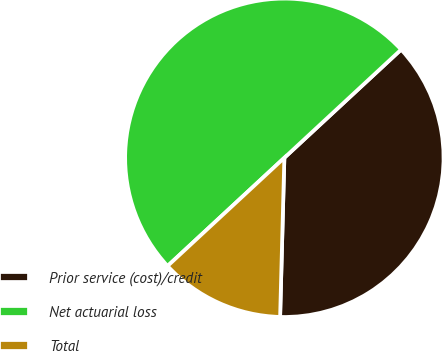Convert chart to OTSL. <chart><loc_0><loc_0><loc_500><loc_500><pie_chart><fcel>Prior service (cost)/credit<fcel>Net actuarial loss<fcel>Total<nl><fcel>37.32%<fcel>50.0%<fcel>12.68%<nl></chart> 